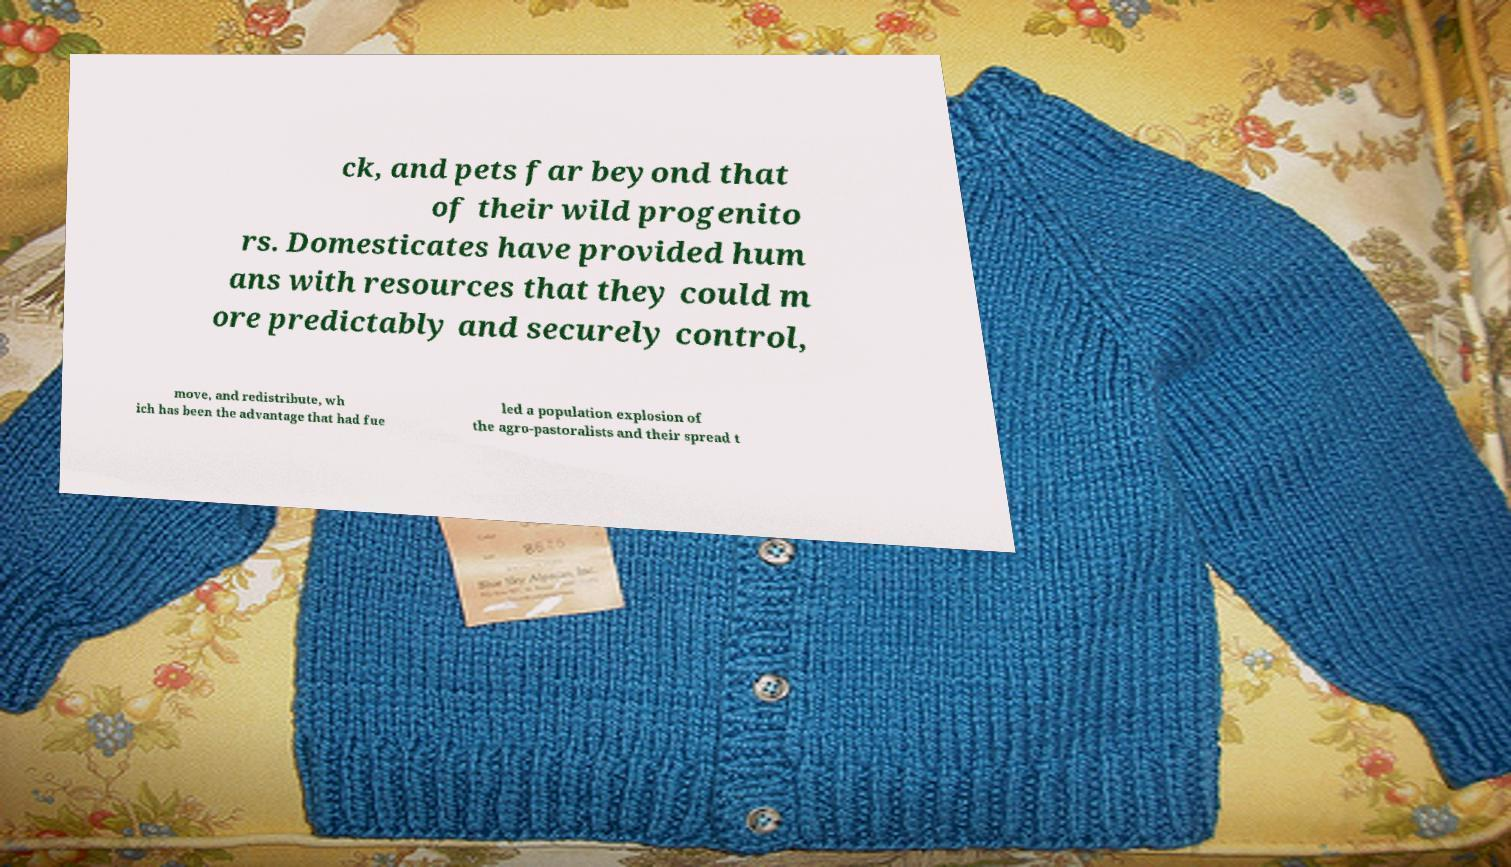There's text embedded in this image that I need extracted. Can you transcribe it verbatim? ck, and pets far beyond that of their wild progenito rs. Domesticates have provided hum ans with resources that they could m ore predictably and securely control, move, and redistribute, wh ich has been the advantage that had fue led a population explosion of the agro-pastoralists and their spread t 